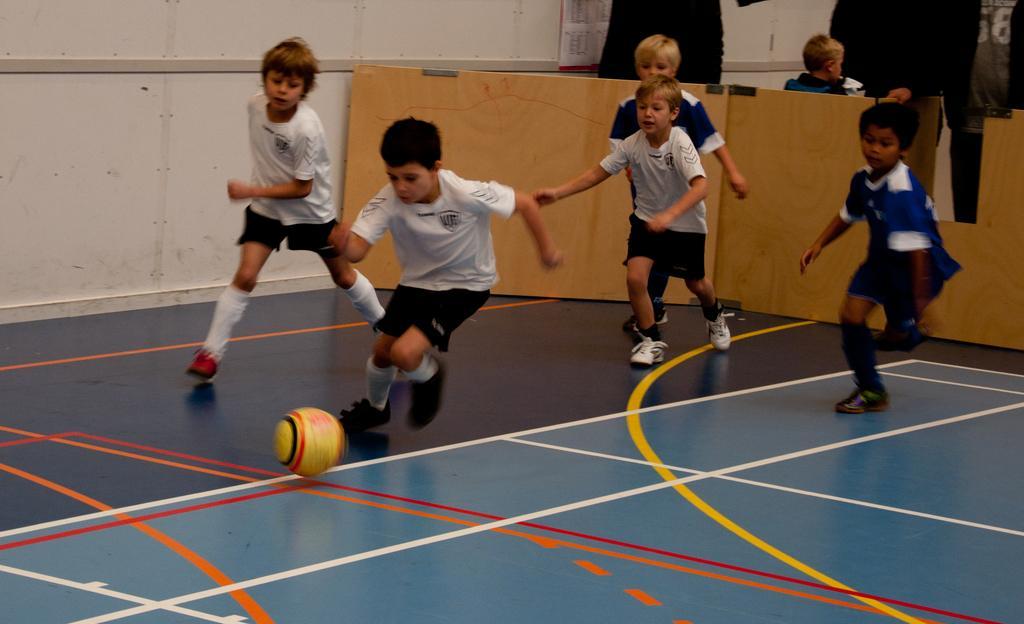Can you describe this image briefly? In the picture I can see children wearing white color T-shirts, blue color T-shirts, socks and shoes are playing in the court. Here I can see the yellow color ball. In the background, I can see another person standing, I can see some objects and a poster on the wall. 